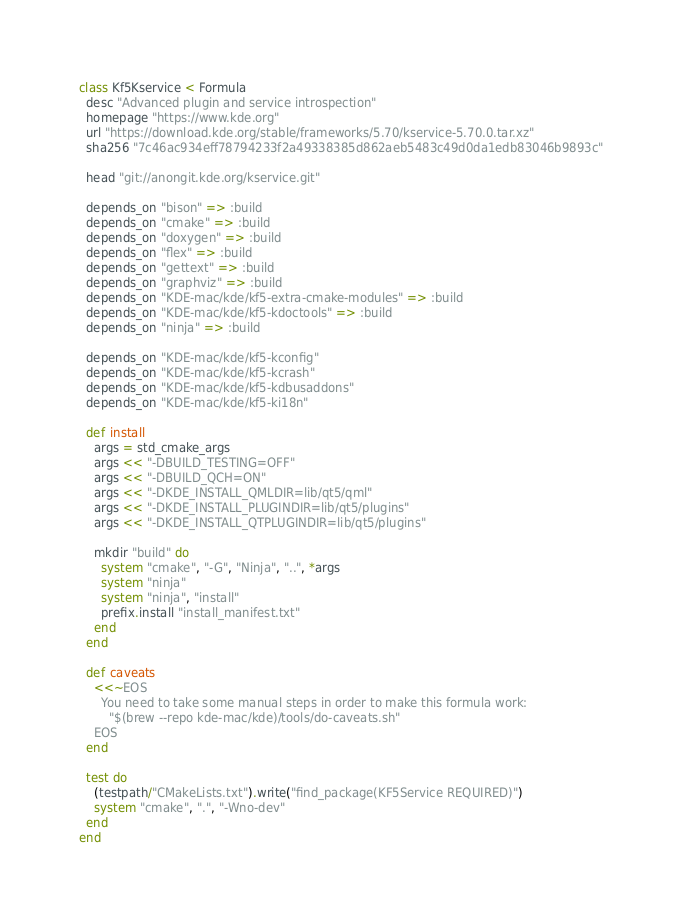Convert code to text. <code><loc_0><loc_0><loc_500><loc_500><_Ruby_>class Kf5Kservice < Formula
  desc "Advanced plugin and service introspection"
  homepage "https://www.kde.org"
  url "https://download.kde.org/stable/frameworks/5.70/kservice-5.70.0.tar.xz"
  sha256 "7c46ac934eff78794233f2a49338385d862aeb5483c49d0da1edb83046b9893c"

  head "git://anongit.kde.org/kservice.git"

  depends_on "bison" => :build
  depends_on "cmake" => :build
  depends_on "doxygen" => :build
  depends_on "flex" => :build
  depends_on "gettext" => :build
  depends_on "graphviz" => :build
  depends_on "KDE-mac/kde/kf5-extra-cmake-modules" => :build
  depends_on "KDE-mac/kde/kf5-kdoctools" => :build
  depends_on "ninja" => :build

  depends_on "KDE-mac/kde/kf5-kconfig"
  depends_on "KDE-mac/kde/kf5-kcrash"
  depends_on "KDE-mac/kde/kf5-kdbusaddons"
  depends_on "KDE-mac/kde/kf5-ki18n"

  def install
    args = std_cmake_args
    args << "-DBUILD_TESTING=OFF"
    args << "-DBUILD_QCH=ON"
    args << "-DKDE_INSTALL_QMLDIR=lib/qt5/qml"
    args << "-DKDE_INSTALL_PLUGINDIR=lib/qt5/plugins"
    args << "-DKDE_INSTALL_QTPLUGINDIR=lib/qt5/plugins"

    mkdir "build" do
      system "cmake", "-G", "Ninja", "..", *args
      system "ninja"
      system "ninja", "install"
      prefix.install "install_manifest.txt"
    end
  end

  def caveats
    <<~EOS
      You need to take some manual steps in order to make this formula work:
        "$(brew --repo kde-mac/kde)/tools/do-caveats.sh"
    EOS
  end

  test do
    (testpath/"CMakeLists.txt").write("find_package(KF5Service REQUIRED)")
    system "cmake", ".", "-Wno-dev"
  end
end
</code> 